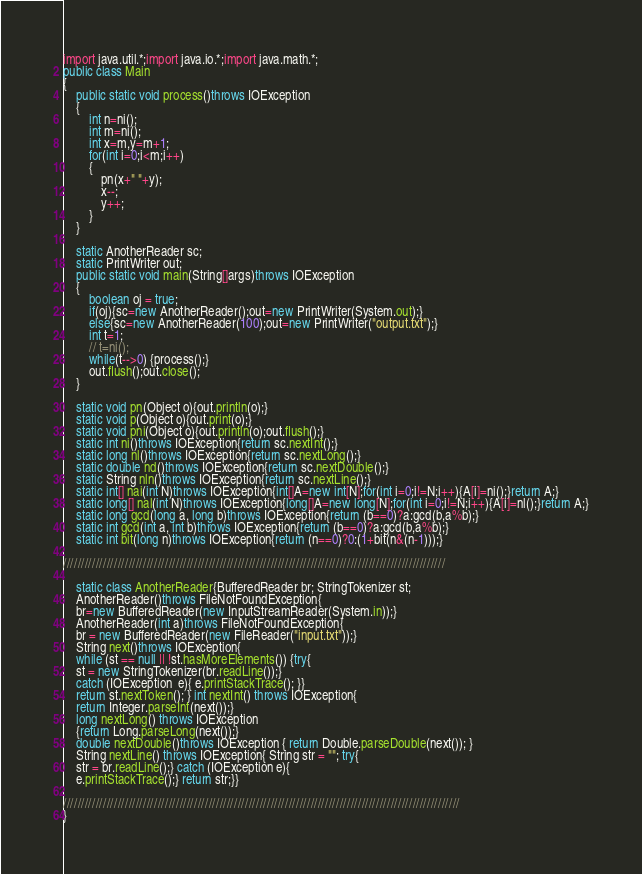<code> <loc_0><loc_0><loc_500><loc_500><_Java_>import java.util.*;import java.io.*;import java.math.*;
public class Main
{
    public static void process()throws IOException
    {
        int n=ni();
        int m=ni();
        int x=m,y=m+1;
        for(int i=0;i<m;i++)
        {
            pn(x+" "+y);
            x--;
            y++;
        }
    }

    static AnotherReader sc;
    static PrintWriter out;
    public static void main(String[]args)throws IOException
    {
        boolean oj = true;
        if(oj){sc=new AnotherReader();out=new PrintWriter(System.out);}
        else{sc=new AnotherReader(100);out=new PrintWriter("output.txt");}
        int t=1;
        // t=ni();
        while(t-->0) {process();}
        out.flush();out.close();  
    }

    static void pn(Object o){out.println(o);}
    static void p(Object o){out.print(o);}
    static void pni(Object o){out.println(o);out.flush();}
    static int ni()throws IOException{return sc.nextInt();}
    static long nl()throws IOException{return sc.nextLong();}
    static double nd()throws IOException{return sc.nextDouble();}
    static String nln()throws IOException{return sc.nextLine();}
    static int[] nai(int N)throws IOException{int[]A=new int[N];for(int i=0;i!=N;i++){A[i]=ni();}return A;}
    static long[] nal(int N)throws IOException{long[]A=new long[N];for(int i=0;i!=N;i++){A[i]=nl();}return A;}
    static long gcd(long a, long b)throws IOException{return (b==0)?a:gcd(b,a%b);}
    static int gcd(int a, int b)throws IOException{return (b==0)?a:gcd(b,a%b);}
    static int bit(long n)throws IOException{return (n==0)?0:(1+bit(n&(n-1)));}

/////////////////////////////////////////////////////////////////////////////////////////////////////////

    static class AnotherReader{BufferedReader br; StringTokenizer st;
    AnotherReader()throws FileNotFoundException{
    br=new BufferedReader(new InputStreamReader(System.in));}
    AnotherReader(int a)throws FileNotFoundException{
    br = new BufferedReader(new FileReader("input.txt"));}
    String next()throws IOException{
    while (st == null || !st.hasMoreElements()) {try{
    st = new StringTokenizer(br.readLine());}
    catch (IOException  e){ e.printStackTrace(); }}
    return st.nextToken(); } int nextInt() throws IOException{
    return Integer.parseInt(next());}
    long nextLong() throws IOException
    {return Long.parseLong(next());}
    double nextDouble()throws IOException { return Double.parseDouble(next()); }
    String nextLine() throws IOException{ String str = ""; try{
    str = br.readLine();} catch (IOException e){
    e.printStackTrace();} return str;}}
   
/////////////////////////////////////////////////////////////////////////////////////////////////////////////
}</code> 